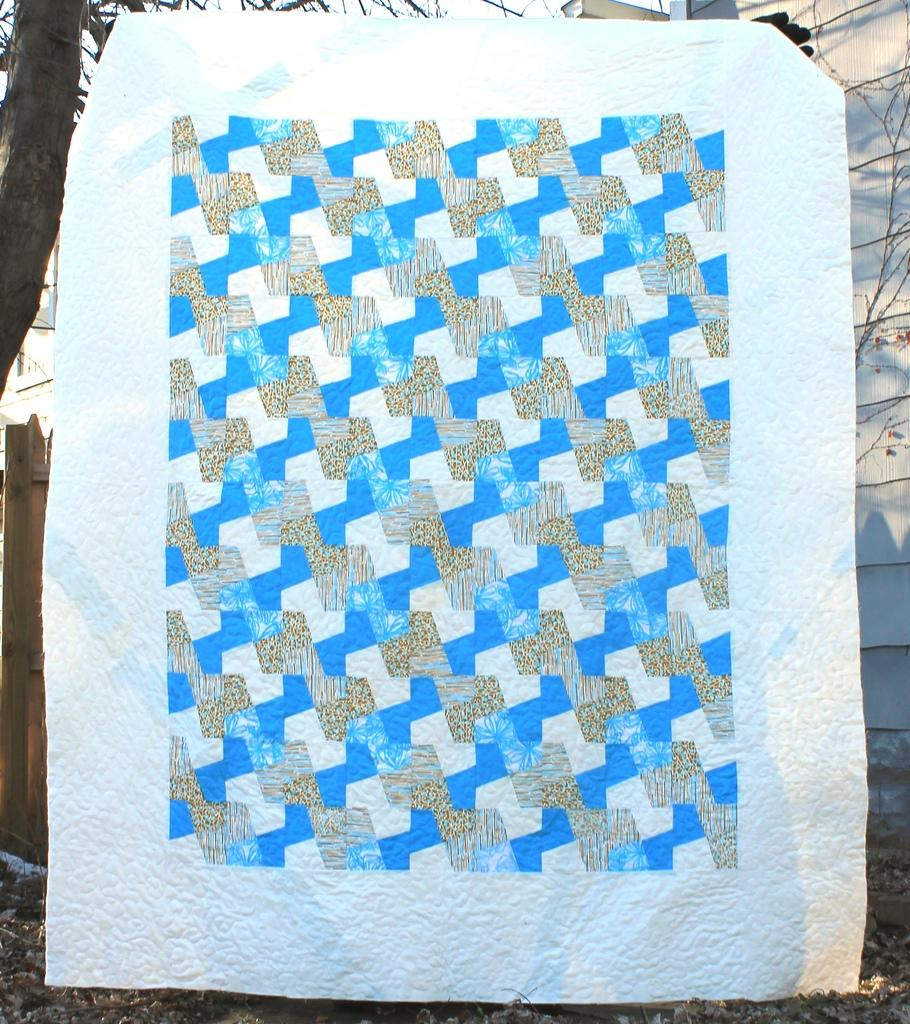What is the main object in the foreground of the image? There is a banner in the image. What can be seen in the background of the image? There is a wall and a tree in the background of the image. What type of shade is provided by the station in the image? There is no station present in the image, and therefore no shade provided by it. 